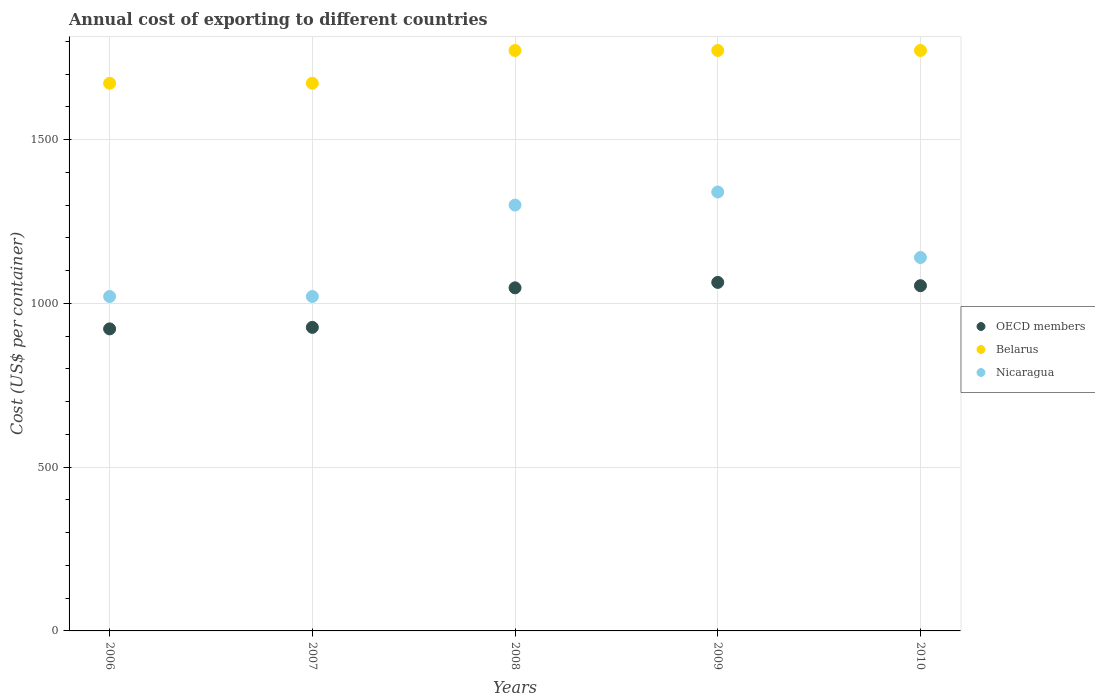How many different coloured dotlines are there?
Ensure brevity in your answer.  3. Is the number of dotlines equal to the number of legend labels?
Your response must be concise. Yes. What is the total annual cost of exporting in Belarus in 2009?
Give a very brief answer. 1772. Across all years, what is the maximum total annual cost of exporting in OECD members?
Keep it short and to the point. 1064. Across all years, what is the minimum total annual cost of exporting in Belarus?
Make the answer very short. 1672. In which year was the total annual cost of exporting in OECD members maximum?
Make the answer very short. 2009. What is the total total annual cost of exporting in OECD members in the graph?
Your answer should be very brief. 5014.24. What is the difference between the total annual cost of exporting in OECD members in 2009 and that in 2010?
Offer a terse response. 10.06. What is the difference between the total annual cost of exporting in Belarus in 2009 and the total annual cost of exporting in Nicaragua in 2007?
Give a very brief answer. 751. What is the average total annual cost of exporting in Belarus per year?
Your response must be concise. 1732. In the year 2006, what is the difference between the total annual cost of exporting in OECD members and total annual cost of exporting in Belarus?
Your response must be concise. -749.88. What is the ratio of the total annual cost of exporting in Nicaragua in 2009 to that in 2010?
Your response must be concise. 1.18. Is the total annual cost of exporting in OECD members in 2006 less than that in 2008?
Offer a terse response. Yes. What is the difference between the highest and the second highest total annual cost of exporting in OECD members?
Give a very brief answer. 10.06. What is the difference between the highest and the lowest total annual cost of exporting in OECD members?
Your response must be concise. 141.88. In how many years, is the total annual cost of exporting in OECD members greater than the average total annual cost of exporting in OECD members taken over all years?
Your answer should be very brief. 3. Is it the case that in every year, the sum of the total annual cost of exporting in Nicaragua and total annual cost of exporting in Belarus  is greater than the total annual cost of exporting in OECD members?
Your answer should be compact. Yes. Is the total annual cost of exporting in Nicaragua strictly greater than the total annual cost of exporting in OECD members over the years?
Offer a terse response. Yes. How many dotlines are there?
Keep it short and to the point. 3. What is the difference between two consecutive major ticks on the Y-axis?
Your response must be concise. 500. Are the values on the major ticks of Y-axis written in scientific E-notation?
Give a very brief answer. No. Does the graph contain any zero values?
Offer a very short reply. No. Where does the legend appear in the graph?
Provide a short and direct response. Center right. How many legend labels are there?
Offer a terse response. 3. How are the legend labels stacked?
Offer a very short reply. Vertical. What is the title of the graph?
Offer a terse response. Annual cost of exporting to different countries. What is the label or title of the X-axis?
Keep it short and to the point. Years. What is the label or title of the Y-axis?
Your answer should be very brief. Cost (US$ per container). What is the Cost (US$ per container) in OECD members in 2006?
Your answer should be very brief. 922.12. What is the Cost (US$ per container) in Belarus in 2006?
Your response must be concise. 1672. What is the Cost (US$ per container) of Nicaragua in 2006?
Ensure brevity in your answer.  1021. What is the Cost (US$ per container) of OECD members in 2007?
Your answer should be very brief. 926.74. What is the Cost (US$ per container) in Belarus in 2007?
Your response must be concise. 1672. What is the Cost (US$ per container) in Nicaragua in 2007?
Ensure brevity in your answer.  1021. What is the Cost (US$ per container) of OECD members in 2008?
Provide a short and direct response. 1047.44. What is the Cost (US$ per container) in Belarus in 2008?
Ensure brevity in your answer.  1772. What is the Cost (US$ per container) of Nicaragua in 2008?
Offer a very short reply. 1300. What is the Cost (US$ per container) in OECD members in 2009?
Provide a short and direct response. 1064. What is the Cost (US$ per container) in Belarus in 2009?
Your response must be concise. 1772. What is the Cost (US$ per container) in Nicaragua in 2009?
Provide a succinct answer. 1340. What is the Cost (US$ per container) in OECD members in 2010?
Ensure brevity in your answer.  1053.94. What is the Cost (US$ per container) of Belarus in 2010?
Make the answer very short. 1772. What is the Cost (US$ per container) of Nicaragua in 2010?
Give a very brief answer. 1140. Across all years, what is the maximum Cost (US$ per container) of OECD members?
Make the answer very short. 1064. Across all years, what is the maximum Cost (US$ per container) of Belarus?
Keep it short and to the point. 1772. Across all years, what is the maximum Cost (US$ per container) in Nicaragua?
Offer a terse response. 1340. Across all years, what is the minimum Cost (US$ per container) of OECD members?
Offer a very short reply. 922.12. Across all years, what is the minimum Cost (US$ per container) of Belarus?
Your answer should be compact. 1672. Across all years, what is the minimum Cost (US$ per container) of Nicaragua?
Provide a short and direct response. 1021. What is the total Cost (US$ per container) in OECD members in the graph?
Your answer should be compact. 5014.24. What is the total Cost (US$ per container) of Belarus in the graph?
Keep it short and to the point. 8660. What is the total Cost (US$ per container) in Nicaragua in the graph?
Provide a succinct answer. 5822. What is the difference between the Cost (US$ per container) of OECD members in 2006 and that in 2007?
Make the answer very short. -4.62. What is the difference between the Cost (US$ per container) in OECD members in 2006 and that in 2008?
Your response must be concise. -125.32. What is the difference between the Cost (US$ per container) of Belarus in 2006 and that in 2008?
Your response must be concise. -100. What is the difference between the Cost (US$ per container) of Nicaragua in 2006 and that in 2008?
Your answer should be very brief. -279. What is the difference between the Cost (US$ per container) in OECD members in 2006 and that in 2009?
Give a very brief answer. -141.88. What is the difference between the Cost (US$ per container) in Belarus in 2006 and that in 2009?
Keep it short and to the point. -100. What is the difference between the Cost (US$ per container) of Nicaragua in 2006 and that in 2009?
Offer a terse response. -319. What is the difference between the Cost (US$ per container) in OECD members in 2006 and that in 2010?
Keep it short and to the point. -131.82. What is the difference between the Cost (US$ per container) of Belarus in 2006 and that in 2010?
Offer a terse response. -100. What is the difference between the Cost (US$ per container) of Nicaragua in 2006 and that in 2010?
Ensure brevity in your answer.  -119. What is the difference between the Cost (US$ per container) in OECD members in 2007 and that in 2008?
Provide a short and direct response. -120.71. What is the difference between the Cost (US$ per container) of Belarus in 2007 and that in 2008?
Your answer should be compact. -100. What is the difference between the Cost (US$ per container) of Nicaragua in 2007 and that in 2008?
Your answer should be very brief. -279. What is the difference between the Cost (US$ per container) of OECD members in 2007 and that in 2009?
Offer a very short reply. -137.26. What is the difference between the Cost (US$ per container) in Belarus in 2007 and that in 2009?
Your answer should be very brief. -100. What is the difference between the Cost (US$ per container) in Nicaragua in 2007 and that in 2009?
Ensure brevity in your answer.  -319. What is the difference between the Cost (US$ per container) in OECD members in 2007 and that in 2010?
Make the answer very short. -127.21. What is the difference between the Cost (US$ per container) of Belarus in 2007 and that in 2010?
Your answer should be compact. -100. What is the difference between the Cost (US$ per container) of Nicaragua in 2007 and that in 2010?
Give a very brief answer. -119. What is the difference between the Cost (US$ per container) in OECD members in 2008 and that in 2009?
Your answer should be compact. -16.56. What is the difference between the Cost (US$ per container) in Belarus in 2008 and that in 2009?
Keep it short and to the point. 0. What is the difference between the Cost (US$ per container) of OECD members in 2008 and that in 2010?
Give a very brief answer. -6.5. What is the difference between the Cost (US$ per container) of Nicaragua in 2008 and that in 2010?
Ensure brevity in your answer.  160. What is the difference between the Cost (US$ per container) of OECD members in 2009 and that in 2010?
Provide a succinct answer. 10.06. What is the difference between the Cost (US$ per container) in Belarus in 2009 and that in 2010?
Offer a very short reply. 0. What is the difference between the Cost (US$ per container) of OECD members in 2006 and the Cost (US$ per container) of Belarus in 2007?
Offer a terse response. -749.88. What is the difference between the Cost (US$ per container) of OECD members in 2006 and the Cost (US$ per container) of Nicaragua in 2007?
Your answer should be very brief. -98.88. What is the difference between the Cost (US$ per container) in Belarus in 2006 and the Cost (US$ per container) in Nicaragua in 2007?
Your answer should be compact. 651. What is the difference between the Cost (US$ per container) of OECD members in 2006 and the Cost (US$ per container) of Belarus in 2008?
Provide a succinct answer. -849.88. What is the difference between the Cost (US$ per container) in OECD members in 2006 and the Cost (US$ per container) in Nicaragua in 2008?
Offer a terse response. -377.88. What is the difference between the Cost (US$ per container) in Belarus in 2006 and the Cost (US$ per container) in Nicaragua in 2008?
Keep it short and to the point. 372. What is the difference between the Cost (US$ per container) of OECD members in 2006 and the Cost (US$ per container) of Belarus in 2009?
Provide a short and direct response. -849.88. What is the difference between the Cost (US$ per container) of OECD members in 2006 and the Cost (US$ per container) of Nicaragua in 2009?
Your response must be concise. -417.88. What is the difference between the Cost (US$ per container) in Belarus in 2006 and the Cost (US$ per container) in Nicaragua in 2009?
Provide a short and direct response. 332. What is the difference between the Cost (US$ per container) of OECD members in 2006 and the Cost (US$ per container) of Belarus in 2010?
Your answer should be very brief. -849.88. What is the difference between the Cost (US$ per container) in OECD members in 2006 and the Cost (US$ per container) in Nicaragua in 2010?
Your answer should be compact. -217.88. What is the difference between the Cost (US$ per container) of Belarus in 2006 and the Cost (US$ per container) of Nicaragua in 2010?
Provide a short and direct response. 532. What is the difference between the Cost (US$ per container) in OECD members in 2007 and the Cost (US$ per container) in Belarus in 2008?
Offer a very short reply. -845.26. What is the difference between the Cost (US$ per container) in OECD members in 2007 and the Cost (US$ per container) in Nicaragua in 2008?
Make the answer very short. -373.26. What is the difference between the Cost (US$ per container) in Belarus in 2007 and the Cost (US$ per container) in Nicaragua in 2008?
Ensure brevity in your answer.  372. What is the difference between the Cost (US$ per container) of OECD members in 2007 and the Cost (US$ per container) of Belarus in 2009?
Your answer should be compact. -845.26. What is the difference between the Cost (US$ per container) in OECD members in 2007 and the Cost (US$ per container) in Nicaragua in 2009?
Your response must be concise. -413.26. What is the difference between the Cost (US$ per container) of Belarus in 2007 and the Cost (US$ per container) of Nicaragua in 2009?
Make the answer very short. 332. What is the difference between the Cost (US$ per container) in OECD members in 2007 and the Cost (US$ per container) in Belarus in 2010?
Provide a short and direct response. -845.26. What is the difference between the Cost (US$ per container) in OECD members in 2007 and the Cost (US$ per container) in Nicaragua in 2010?
Ensure brevity in your answer.  -213.26. What is the difference between the Cost (US$ per container) of Belarus in 2007 and the Cost (US$ per container) of Nicaragua in 2010?
Provide a short and direct response. 532. What is the difference between the Cost (US$ per container) of OECD members in 2008 and the Cost (US$ per container) of Belarus in 2009?
Keep it short and to the point. -724.56. What is the difference between the Cost (US$ per container) in OECD members in 2008 and the Cost (US$ per container) in Nicaragua in 2009?
Make the answer very short. -292.56. What is the difference between the Cost (US$ per container) of Belarus in 2008 and the Cost (US$ per container) of Nicaragua in 2009?
Provide a short and direct response. 432. What is the difference between the Cost (US$ per container) in OECD members in 2008 and the Cost (US$ per container) in Belarus in 2010?
Provide a succinct answer. -724.56. What is the difference between the Cost (US$ per container) of OECD members in 2008 and the Cost (US$ per container) of Nicaragua in 2010?
Provide a succinct answer. -92.56. What is the difference between the Cost (US$ per container) in Belarus in 2008 and the Cost (US$ per container) in Nicaragua in 2010?
Offer a terse response. 632. What is the difference between the Cost (US$ per container) of OECD members in 2009 and the Cost (US$ per container) of Belarus in 2010?
Offer a terse response. -708. What is the difference between the Cost (US$ per container) in OECD members in 2009 and the Cost (US$ per container) in Nicaragua in 2010?
Ensure brevity in your answer.  -76. What is the difference between the Cost (US$ per container) in Belarus in 2009 and the Cost (US$ per container) in Nicaragua in 2010?
Offer a terse response. 632. What is the average Cost (US$ per container) in OECD members per year?
Your response must be concise. 1002.85. What is the average Cost (US$ per container) of Belarus per year?
Offer a terse response. 1732. What is the average Cost (US$ per container) in Nicaragua per year?
Provide a short and direct response. 1164.4. In the year 2006, what is the difference between the Cost (US$ per container) of OECD members and Cost (US$ per container) of Belarus?
Your response must be concise. -749.88. In the year 2006, what is the difference between the Cost (US$ per container) in OECD members and Cost (US$ per container) in Nicaragua?
Offer a very short reply. -98.88. In the year 2006, what is the difference between the Cost (US$ per container) in Belarus and Cost (US$ per container) in Nicaragua?
Make the answer very short. 651. In the year 2007, what is the difference between the Cost (US$ per container) in OECD members and Cost (US$ per container) in Belarus?
Offer a terse response. -745.26. In the year 2007, what is the difference between the Cost (US$ per container) of OECD members and Cost (US$ per container) of Nicaragua?
Ensure brevity in your answer.  -94.26. In the year 2007, what is the difference between the Cost (US$ per container) of Belarus and Cost (US$ per container) of Nicaragua?
Keep it short and to the point. 651. In the year 2008, what is the difference between the Cost (US$ per container) of OECD members and Cost (US$ per container) of Belarus?
Keep it short and to the point. -724.56. In the year 2008, what is the difference between the Cost (US$ per container) of OECD members and Cost (US$ per container) of Nicaragua?
Offer a very short reply. -252.56. In the year 2008, what is the difference between the Cost (US$ per container) in Belarus and Cost (US$ per container) in Nicaragua?
Provide a succinct answer. 472. In the year 2009, what is the difference between the Cost (US$ per container) in OECD members and Cost (US$ per container) in Belarus?
Make the answer very short. -708. In the year 2009, what is the difference between the Cost (US$ per container) of OECD members and Cost (US$ per container) of Nicaragua?
Ensure brevity in your answer.  -276. In the year 2009, what is the difference between the Cost (US$ per container) in Belarus and Cost (US$ per container) in Nicaragua?
Your response must be concise. 432. In the year 2010, what is the difference between the Cost (US$ per container) of OECD members and Cost (US$ per container) of Belarus?
Your answer should be compact. -718.06. In the year 2010, what is the difference between the Cost (US$ per container) in OECD members and Cost (US$ per container) in Nicaragua?
Make the answer very short. -86.06. In the year 2010, what is the difference between the Cost (US$ per container) of Belarus and Cost (US$ per container) of Nicaragua?
Your answer should be compact. 632. What is the ratio of the Cost (US$ per container) of OECD members in 2006 to that in 2007?
Make the answer very short. 0.99. What is the ratio of the Cost (US$ per container) in Nicaragua in 2006 to that in 2007?
Your response must be concise. 1. What is the ratio of the Cost (US$ per container) of OECD members in 2006 to that in 2008?
Provide a short and direct response. 0.88. What is the ratio of the Cost (US$ per container) of Belarus in 2006 to that in 2008?
Make the answer very short. 0.94. What is the ratio of the Cost (US$ per container) in Nicaragua in 2006 to that in 2008?
Offer a very short reply. 0.79. What is the ratio of the Cost (US$ per container) of OECD members in 2006 to that in 2009?
Offer a very short reply. 0.87. What is the ratio of the Cost (US$ per container) of Belarus in 2006 to that in 2009?
Your response must be concise. 0.94. What is the ratio of the Cost (US$ per container) of Nicaragua in 2006 to that in 2009?
Make the answer very short. 0.76. What is the ratio of the Cost (US$ per container) in OECD members in 2006 to that in 2010?
Offer a terse response. 0.87. What is the ratio of the Cost (US$ per container) in Belarus in 2006 to that in 2010?
Your answer should be very brief. 0.94. What is the ratio of the Cost (US$ per container) of Nicaragua in 2006 to that in 2010?
Keep it short and to the point. 0.9. What is the ratio of the Cost (US$ per container) of OECD members in 2007 to that in 2008?
Your response must be concise. 0.88. What is the ratio of the Cost (US$ per container) of Belarus in 2007 to that in 2008?
Your answer should be very brief. 0.94. What is the ratio of the Cost (US$ per container) of Nicaragua in 2007 to that in 2008?
Provide a succinct answer. 0.79. What is the ratio of the Cost (US$ per container) in OECD members in 2007 to that in 2009?
Offer a terse response. 0.87. What is the ratio of the Cost (US$ per container) in Belarus in 2007 to that in 2009?
Keep it short and to the point. 0.94. What is the ratio of the Cost (US$ per container) of Nicaragua in 2007 to that in 2009?
Keep it short and to the point. 0.76. What is the ratio of the Cost (US$ per container) in OECD members in 2007 to that in 2010?
Your response must be concise. 0.88. What is the ratio of the Cost (US$ per container) of Belarus in 2007 to that in 2010?
Your answer should be very brief. 0.94. What is the ratio of the Cost (US$ per container) of Nicaragua in 2007 to that in 2010?
Your answer should be very brief. 0.9. What is the ratio of the Cost (US$ per container) in OECD members in 2008 to that in 2009?
Your answer should be very brief. 0.98. What is the ratio of the Cost (US$ per container) of Belarus in 2008 to that in 2009?
Offer a terse response. 1. What is the ratio of the Cost (US$ per container) in Nicaragua in 2008 to that in 2009?
Offer a terse response. 0.97. What is the ratio of the Cost (US$ per container) of OECD members in 2008 to that in 2010?
Provide a succinct answer. 0.99. What is the ratio of the Cost (US$ per container) in Belarus in 2008 to that in 2010?
Offer a very short reply. 1. What is the ratio of the Cost (US$ per container) in Nicaragua in 2008 to that in 2010?
Ensure brevity in your answer.  1.14. What is the ratio of the Cost (US$ per container) of OECD members in 2009 to that in 2010?
Your answer should be compact. 1.01. What is the ratio of the Cost (US$ per container) in Belarus in 2009 to that in 2010?
Keep it short and to the point. 1. What is the ratio of the Cost (US$ per container) of Nicaragua in 2009 to that in 2010?
Your response must be concise. 1.18. What is the difference between the highest and the second highest Cost (US$ per container) in OECD members?
Offer a very short reply. 10.06. What is the difference between the highest and the second highest Cost (US$ per container) in Nicaragua?
Provide a succinct answer. 40. What is the difference between the highest and the lowest Cost (US$ per container) in OECD members?
Offer a terse response. 141.88. What is the difference between the highest and the lowest Cost (US$ per container) in Nicaragua?
Keep it short and to the point. 319. 